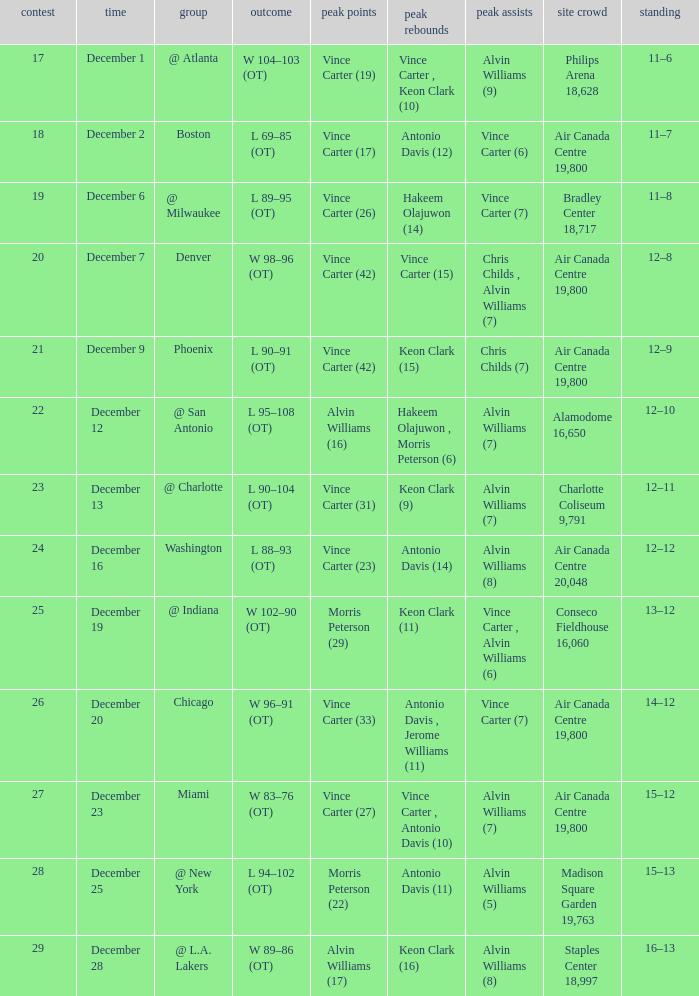What game happened on December 19? 25.0. 